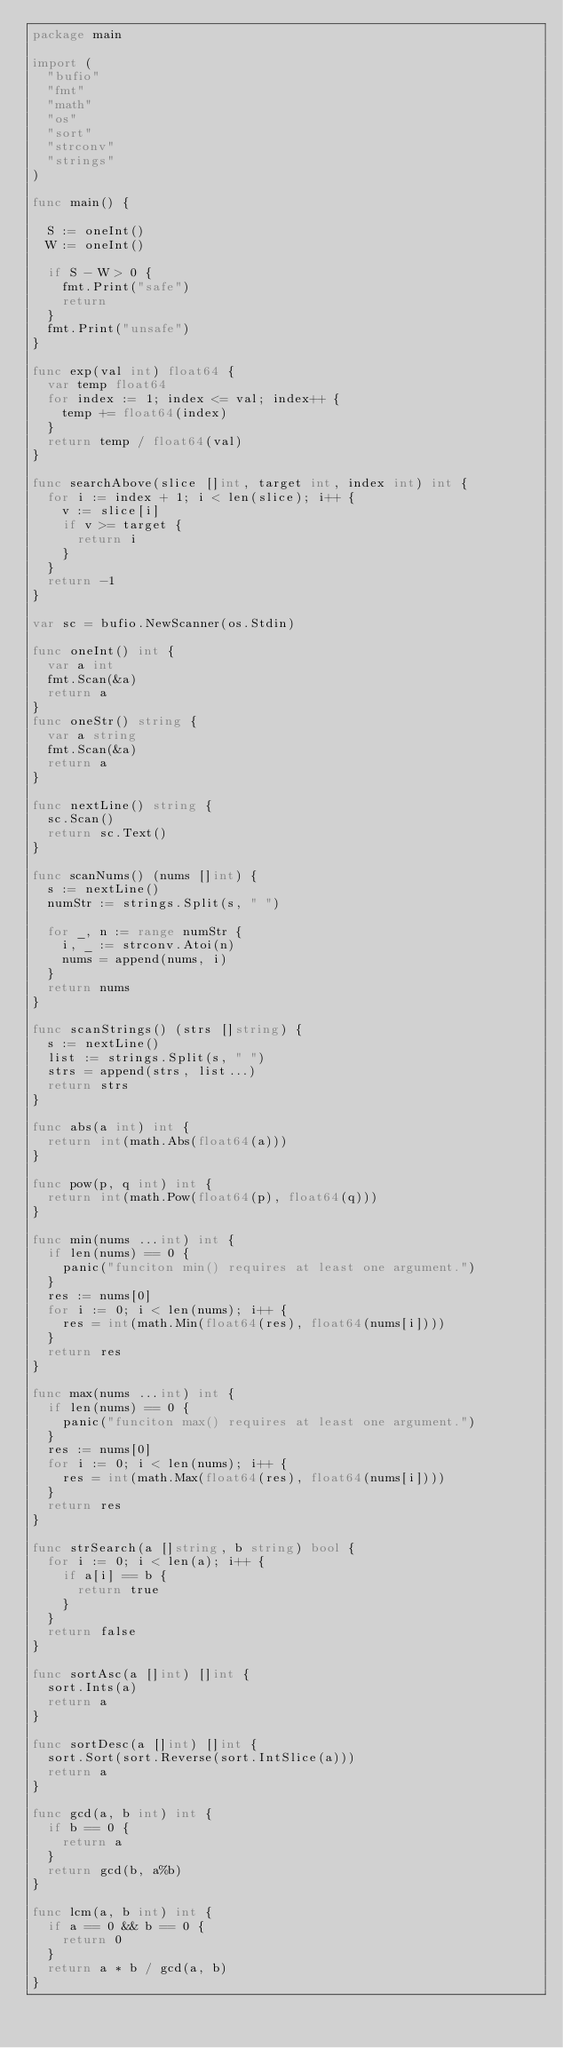<code> <loc_0><loc_0><loc_500><loc_500><_Go_>package main

import (
	"bufio"
	"fmt"
	"math"
	"os"
	"sort"
	"strconv"
	"strings"
)

func main() {

	S := oneInt()
	W := oneInt()
  
  if S - W > 0 {
    fmt.Print("safe")
    return
  }
  fmt.Print("unsafe")
}

func exp(val int) float64 {
	var temp float64
	for index := 1; index <= val; index++ {
		temp += float64(index)
	}
	return temp / float64(val)
}

func searchAbove(slice []int, target int, index int) int {
	for i := index + 1; i < len(slice); i++ {
		v := slice[i]
		if v >= target {
			return i
		}
	}
	return -1
}

var sc = bufio.NewScanner(os.Stdin)

func oneInt() int {
	var a int
	fmt.Scan(&a)
	return a
}
func oneStr() string {
	var a string
	fmt.Scan(&a)
	return a
}

func nextLine() string {
	sc.Scan()
	return sc.Text()
}

func scanNums() (nums []int) {
	s := nextLine()
	numStr := strings.Split(s, " ")

	for _, n := range numStr {
		i, _ := strconv.Atoi(n)
		nums = append(nums, i)
	}
	return nums
}

func scanStrings() (strs []string) {
	s := nextLine()
	list := strings.Split(s, " ")
	strs = append(strs, list...)
	return strs
}

func abs(a int) int {
	return int(math.Abs(float64(a)))
}

func pow(p, q int) int {
	return int(math.Pow(float64(p), float64(q)))
}

func min(nums ...int) int {
	if len(nums) == 0 {
		panic("funciton min() requires at least one argument.")
	}
	res := nums[0]
	for i := 0; i < len(nums); i++ {
		res = int(math.Min(float64(res), float64(nums[i])))
	}
	return res
}

func max(nums ...int) int {
	if len(nums) == 0 {
		panic("funciton max() requires at least one argument.")
	}
	res := nums[0]
	for i := 0; i < len(nums); i++ {
		res = int(math.Max(float64(res), float64(nums[i])))
	}
	return res
}

func strSearch(a []string, b string) bool {
	for i := 0; i < len(a); i++ {
		if a[i] == b {
			return true
		}
	}
	return false
}

func sortAsc(a []int) []int {
	sort.Ints(a)
	return a
}

func sortDesc(a []int) []int {
	sort.Sort(sort.Reverse(sort.IntSlice(a)))
	return a
}

func gcd(a, b int) int {
	if b == 0 {
		return a
	}
	return gcd(b, a%b)
}

func lcm(a, b int) int {
	if a == 0 && b == 0 {
		return 0
	}
	return a * b / gcd(a, b)
}
</code> 